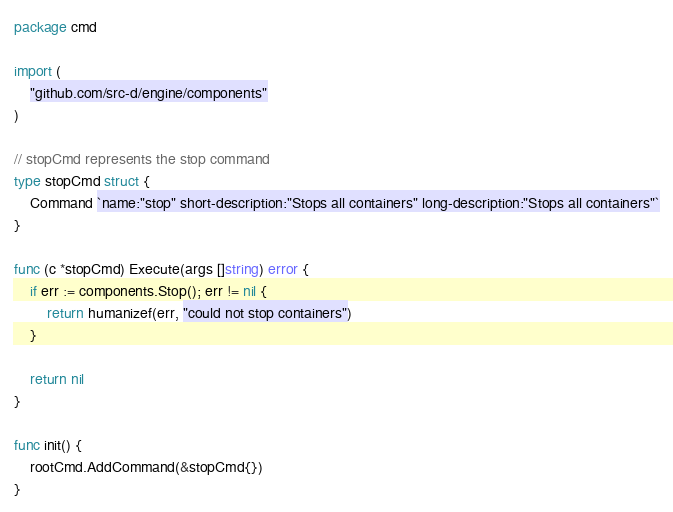Convert code to text. <code><loc_0><loc_0><loc_500><loc_500><_Go_>package cmd

import (
	"github.com/src-d/engine/components"
)

// stopCmd represents the stop command
type stopCmd struct {
	Command `name:"stop" short-description:"Stops all containers" long-description:"Stops all containers"`
}

func (c *stopCmd) Execute(args []string) error {
	if err := components.Stop(); err != nil {
		return humanizef(err, "could not stop containers")
	}

	return nil
}

func init() {
	rootCmd.AddCommand(&stopCmd{})
}
</code> 